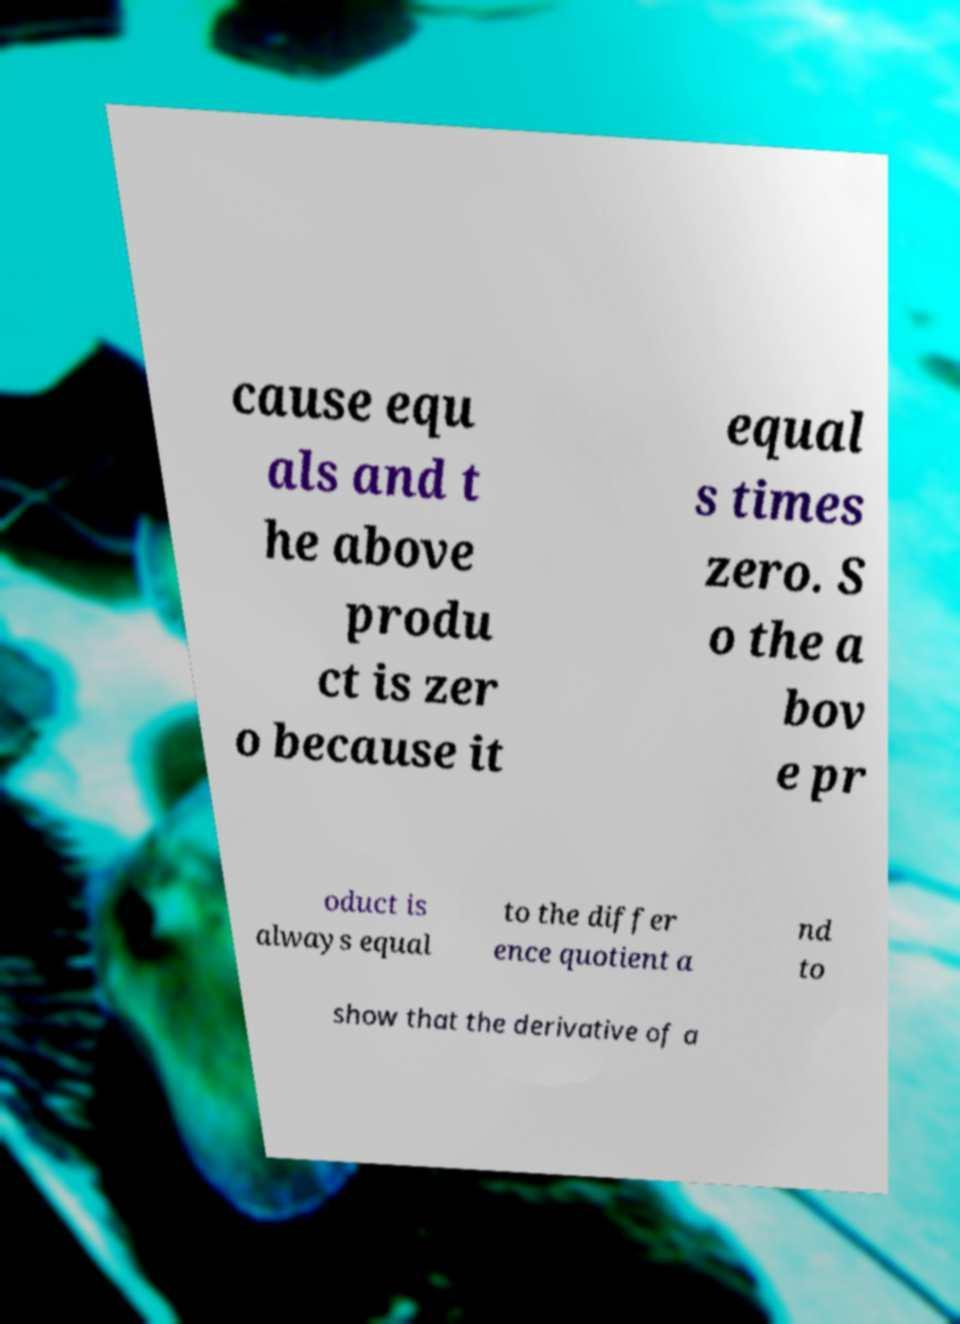There's text embedded in this image that I need extracted. Can you transcribe it verbatim? cause equ als and t he above produ ct is zer o because it equal s times zero. S o the a bov e pr oduct is always equal to the differ ence quotient a nd to show that the derivative of a 